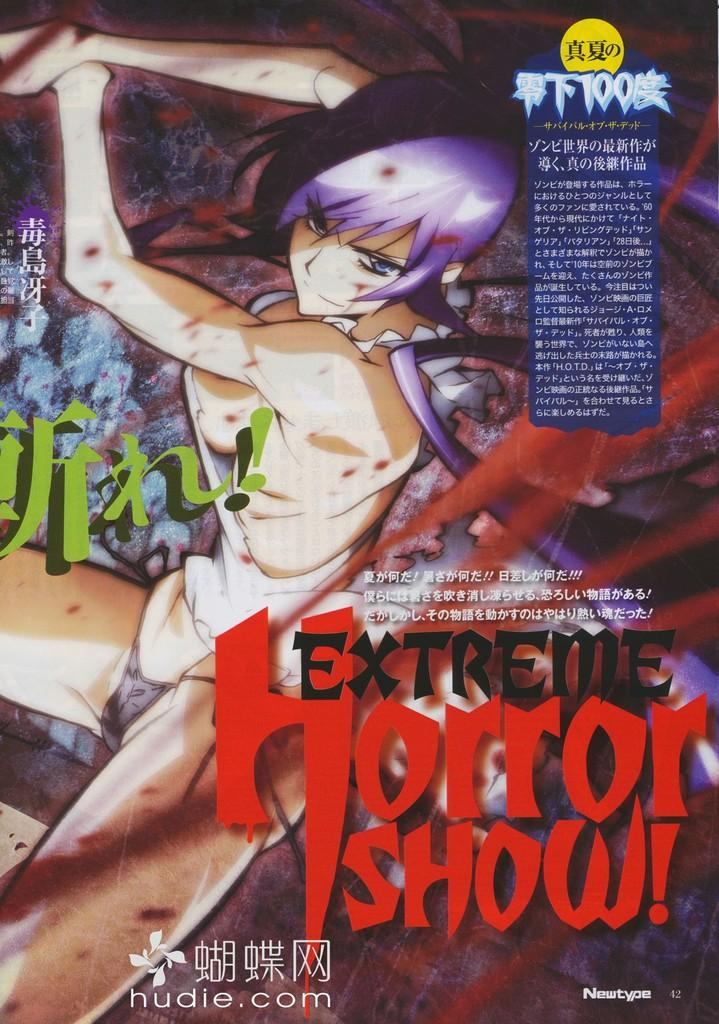What is present on the poster in the image? There is a poster in the image, and it has an image and text on it. Can you describe the image on the poster? The provided facts do not give specific details about the image on the poster. What information is conveyed through the text on the poster? The provided facts do not give specific details about the text on the poster. Can you see the family playing with a yak in the image? There is no family or yak present in the image; it only features a poster with an image and text on it. Is there a rifle visible in the image? There is no rifle present in the image; it only features a poster with an image and text on it. 